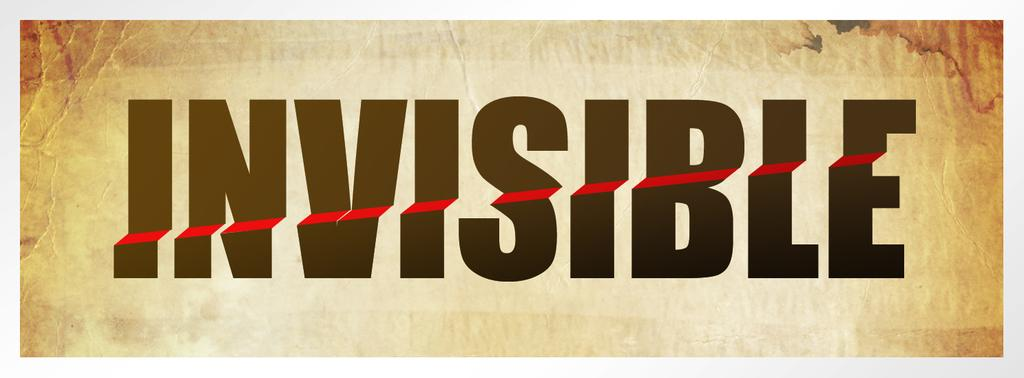<image>
Write a terse but informative summary of the picture. The word Invisible in black with a red line through it 